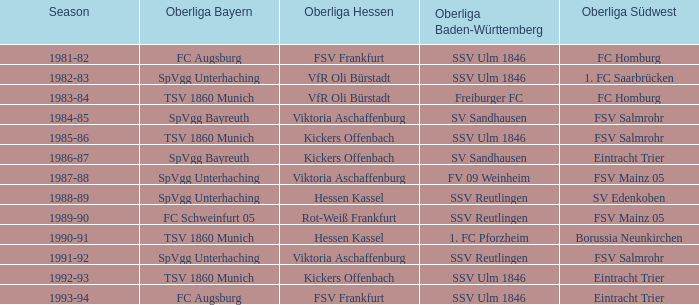Which Oberliga Baden-Württemberg has an Oberliga Hessen of fsv frankfurt in 1993-94? SSV Ulm 1846. 